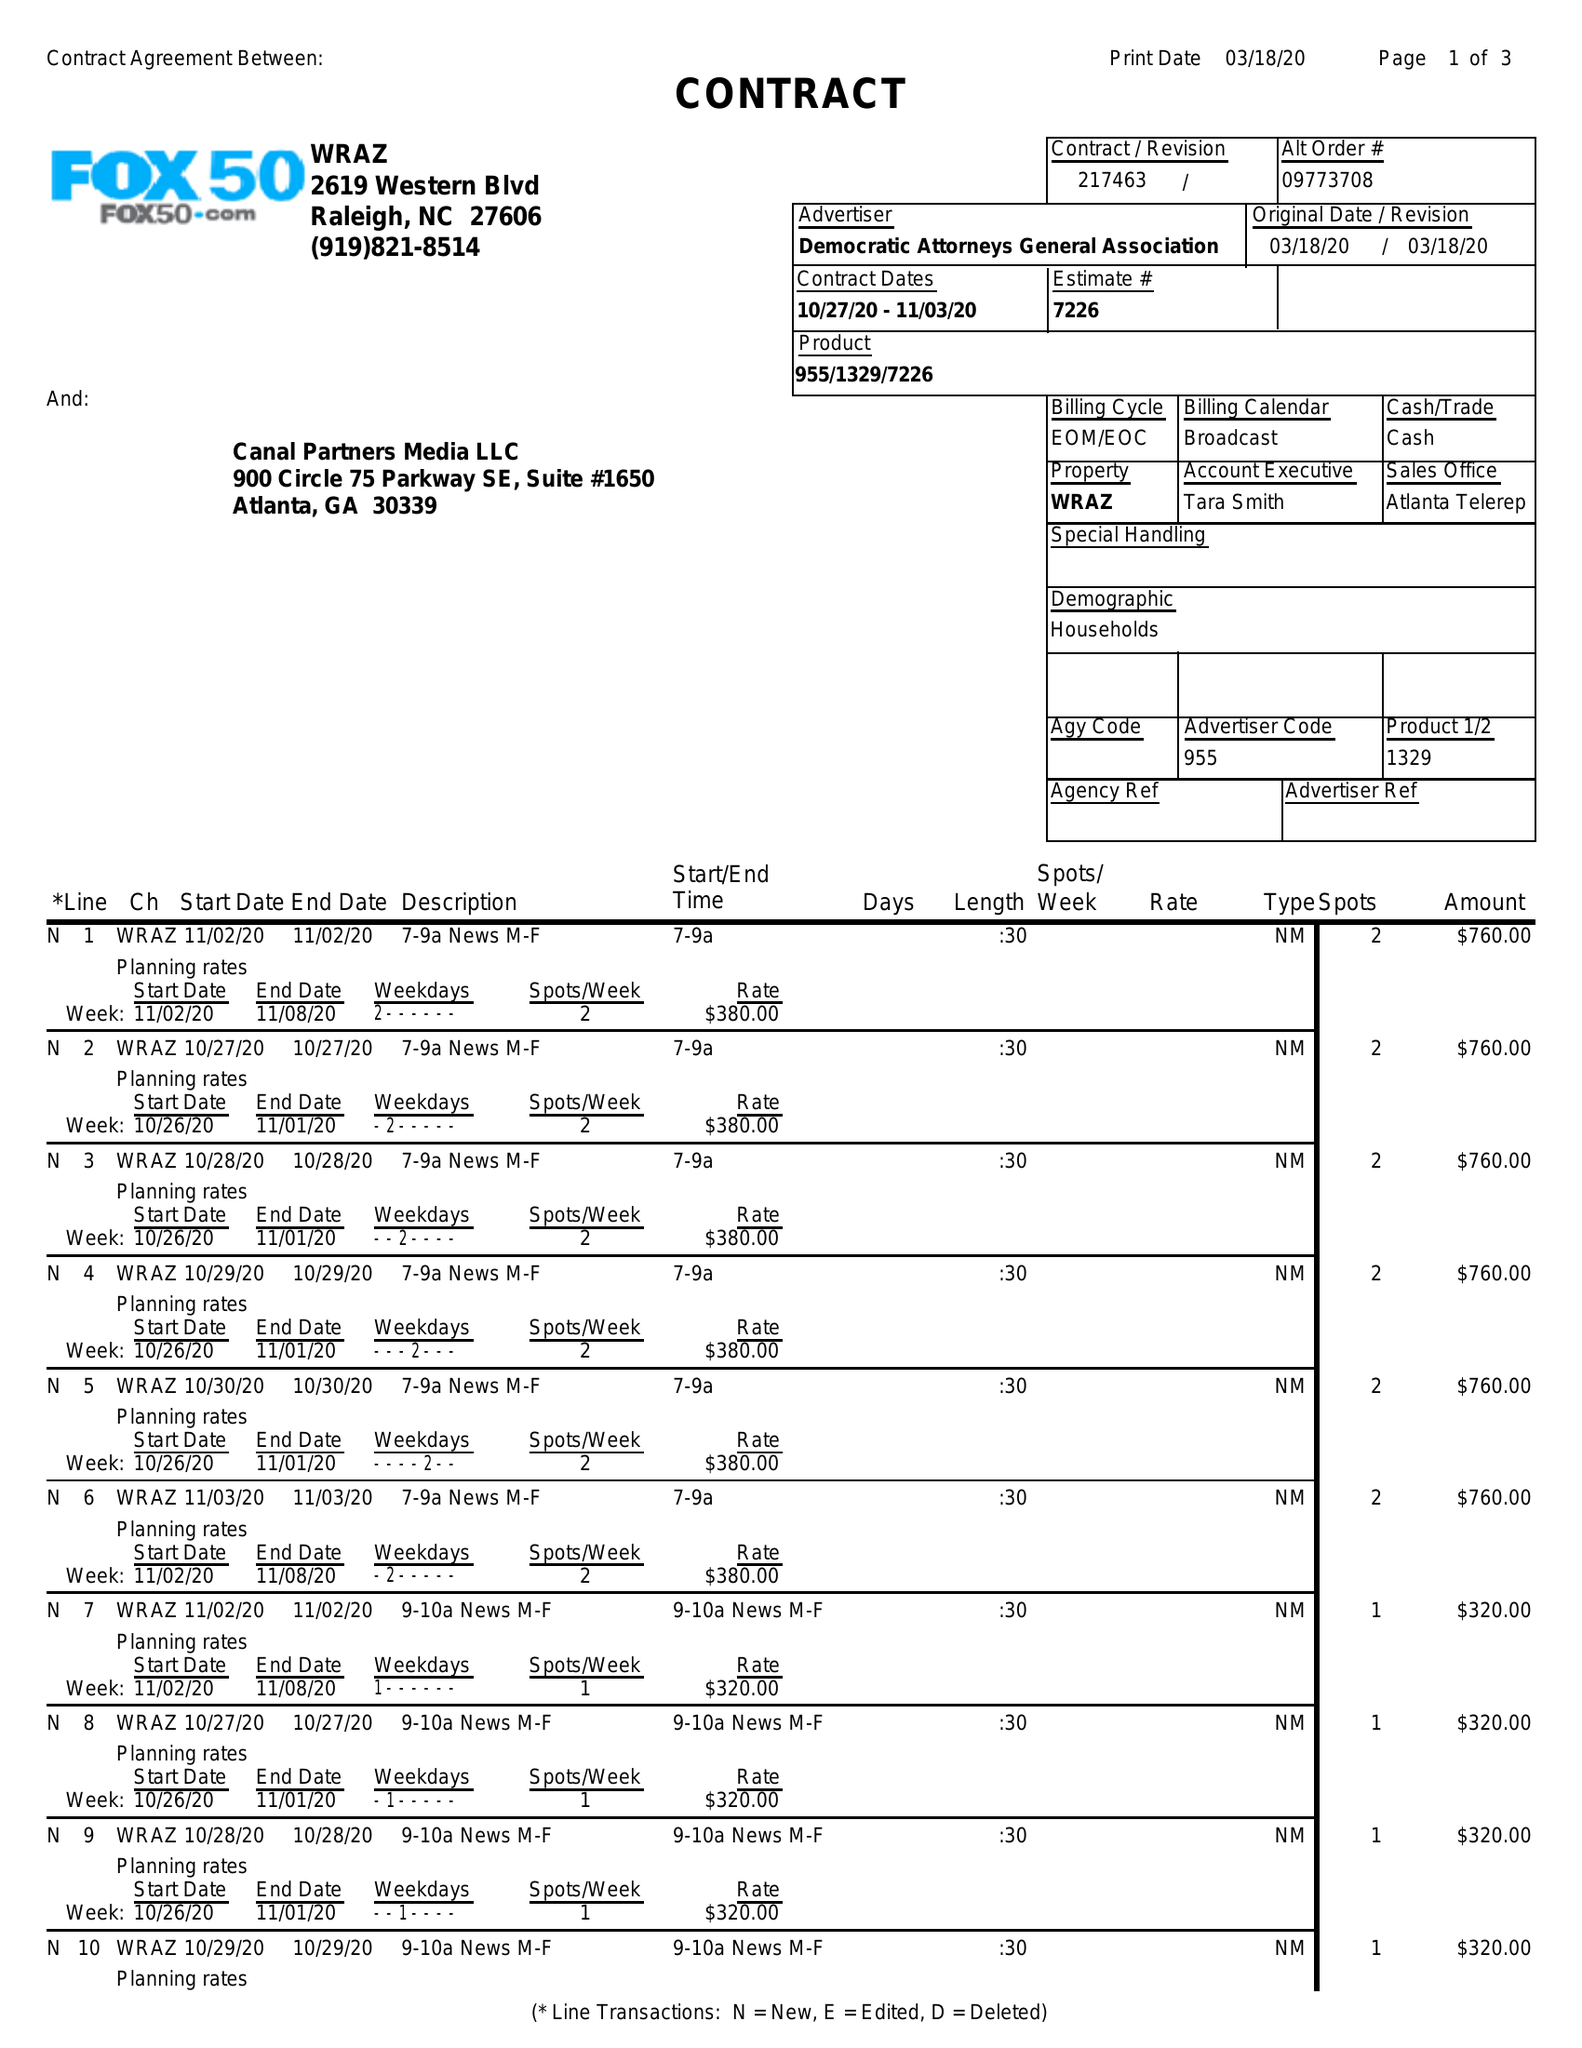What is the value for the flight_to?
Answer the question using a single word or phrase. 11/03/20 